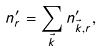<formula> <loc_0><loc_0><loc_500><loc_500>n ^ { \prime } _ { r } = \sum _ { \vec { k } } n ^ { \prime } _ { \vec { k } , r } ,</formula> 